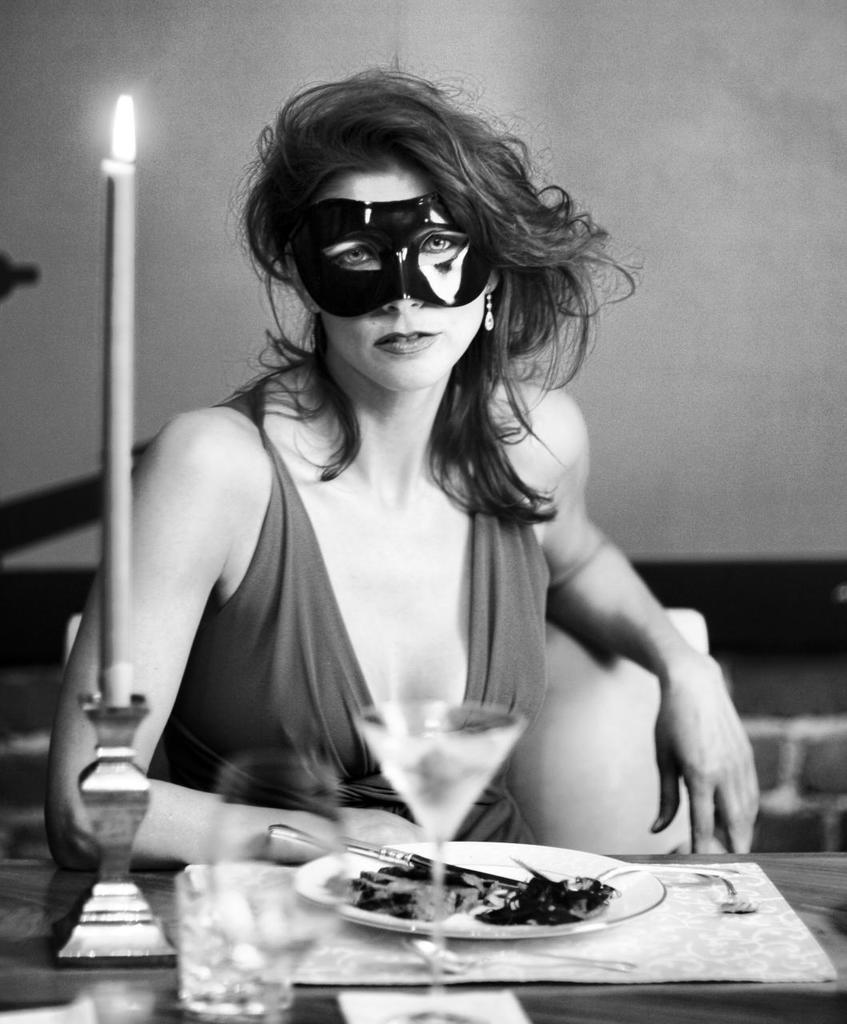What is the woman doing in the image? The woman is sitting in the image. What is on the table with the woman? There is a plate and a candle on the table. What is the location of the objects in the image? The objects are on a table. What can be seen in the background of the image? There is a wall visible in the background of the image. How does the mailbox move around in the image? There is no mailbox present in the image. What type of bottle is visible on the table in the image? There is no bottle present on the table in the image. 